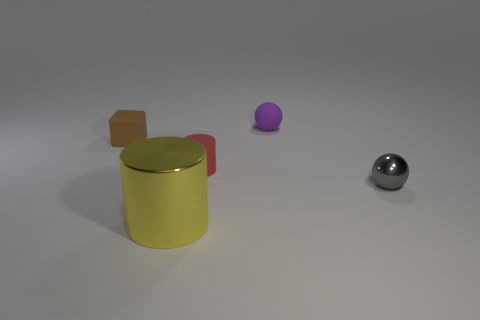Is the color of the small metallic ball the same as the big object?
Your response must be concise. No. Is there anything else that is the same material as the tiny purple sphere?
Provide a short and direct response. Yes. How many objects are either small green metal objects or small red matte cylinders in front of the brown matte cube?
Make the answer very short. 1. There is a matte thing to the left of the red cylinder; is it the same size as the tiny purple rubber thing?
Keep it short and to the point. Yes. What number of other objects are the same shape as the tiny purple matte object?
Make the answer very short. 1. How many gray things are either tiny rubber spheres or large cylinders?
Your answer should be compact. 0. There is a tiny object that is to the left of the yellow object; does it have the same color as the metal cylinder?
Offer a terse response. No. What shape is the gray thing that is made of the same material as the yellow cylinder?
Offer a very short reply. Sphere. The tiny matte object that is both behind the red cylinder and on the left side of the purple matte object is what color?
Your answer should be very brief. Brown. What is the size of the purple rubber object that is on the left side of the tiny sphere that is in front of the cube?
Your answer should be compact. Small. 